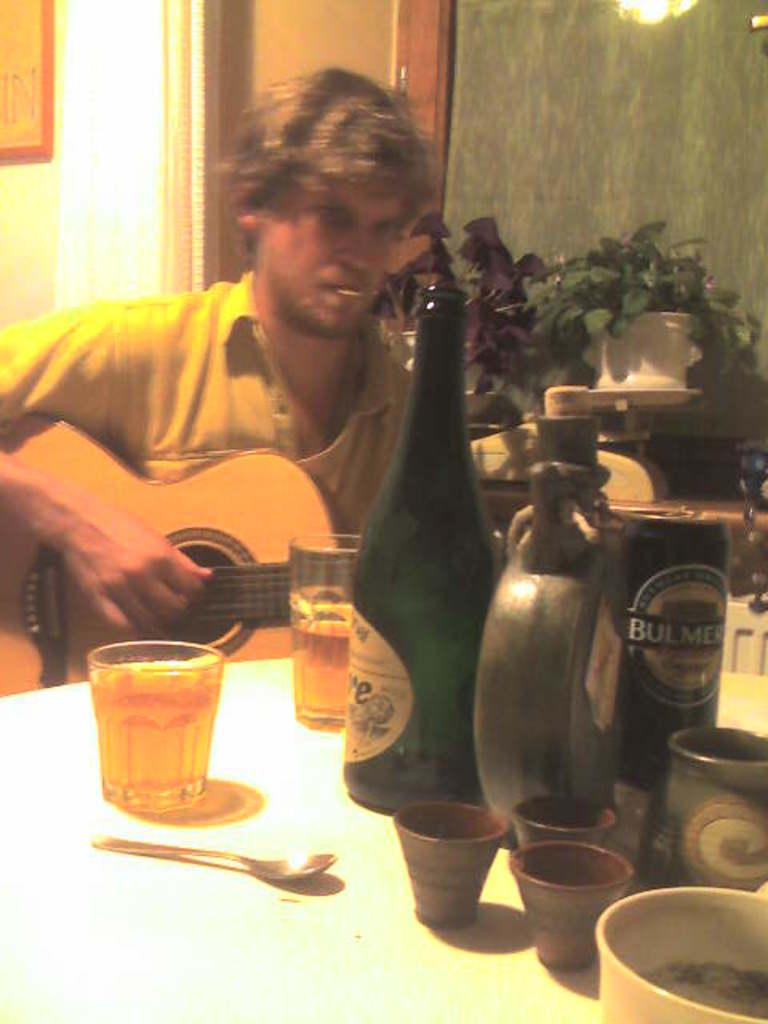<image>
Write a terse but informative summary of the picture. A man plays guitar in front of a table that has a Bulmer can on it. 